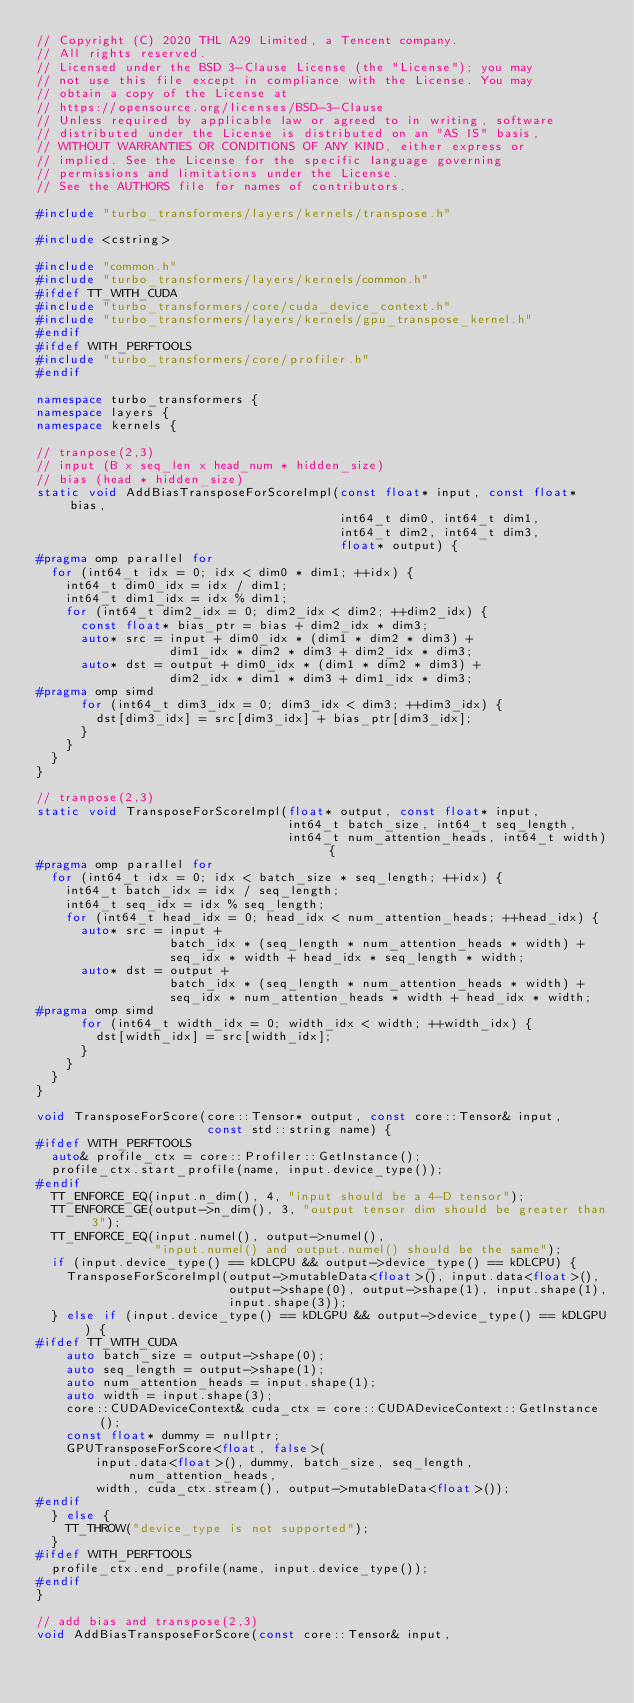Convert code to text. <code><loc_0><loc_0><loc_500><loc_500><_C++_>// Copyright (C) 2020 THL A29 Limited, a Tencent company.
// All rights reserved.
// Licensed under the BSD 3-Clause License (the "License"); you may
// not use this file except in compliance with the License. You may
// obtain a copy of the License at
// https://opensource.org/licenses/BSD-3-Clause
// Unless required by applicable law or agreed to in writing, software
// distributed under the License is distributed on an "AS IS" basis,
// WITHOUT WARRANTIES OR CONDITIONS OF ANY KIND, either express or
// implied. See the License for the specific language governing
// permissions and limitations under the License.
// See the AUTHORS file for names of contributors.

#include "turbo_transformers/layers/kernels/transpose.h"

#include <cstring>

#include "common.h"
#include "turbo_transformers/layers/kernels/common.h"
#ifdef TT_WITH_CUDA
#include "turbo_transformers/core/cuda_device_context.h"
#include "turbo_transformers/layers/kernels/gpu_transpose_kernel.h"
#endif
#ifdef WITH_PERFTOOLS
#include "turbo_transformers/core/profiler.h"
#endif

namespace turbo_transformers {
namespace layers {
namespace kernels {

// tranpose(2,3)
// input (B x seq_len x head_num * hidden_size)
// bias (head * hidden_size)
static void AddBiasTransposeForScoreImpl(const float* input, const float* bias,
                                         int64_t dim0, int64_t dim1,
                                         int64_t dim2, int64_t dim3,
                                         float* output) {
#pragma omp parallel for
  for (int64_t idx = 0; idx < dim0 * dim1; ++idx) {
    int64_t dim0_idx = idx / dim1;
    int64_t dim1_idx = idx % dim1;
    for (int64_t dim2_idx = 0; dim2_idx < dim2; ++dim2_idx) {
      const float* bias_ptr = bias + dim2_idx * dim3;
      auto* src = input + dim0_idx * (dim1 * dim2 * dim3) +
                  dim1_idx * dim2 * dim3 + dim2_idx * dim3;
      auto* dst = output + dim0_idx * (dim1 * dim2 * dim3) +
                  dim2_idx * dim1 * dim3 + dim1_idx * dim3;
#pragma omp simd
      for (int64_t dim3_idx = 0; dim3_idx < dim3; ++dim3_idx) {
        dst[dim3_idx] = src[dim3_idx] + bias_ptr[dim3_idx];
      }
    }
  }
}

// tranpose(2,3)
static void TransposeForScoreImpl(float* output, const float* input,
                                  int64_t batch_size, int64_t seq_length,
                                  int64_t num_attention_heads, int64_t width) {
#pragma omp parallel for
  for (int64_t idx = 0; idx < batch_size * seq_length; ++idx) {
    int64_t batch_idx = idx / seq_length;
    int64_t seq_idx = idx % seq_length;
    for (int64_t head_idx = 0; head_idx < num_attention_heads; ++head_idx) {
      auto* src = input +
                  batch_idx * (seq_length * num_attention_heads * width) +
                  seq_idx * width + head_idx * seq_length * width;
      auto* dst = output +
                  batch_idx * (seq_length * num_attention_heads * width) +
                  seq_idx * num_attention_heads * width + head_idx * width;
#pragma omp simd
      for (int64_t width_idx = 0; width_idx < width; ++width_idx) {
        dst[width_idx] = src[width_idx];
      }
    }
  }
}

void TransposeForScore(core::Tensor* output, const core::Tensor& input,
                       const std::string name) {
#ifdef WITH_PERFTOOLS
  auto& profile_ctx = core::Profiler::GetInstance();
  profile_ctx.start_profile(name, input.device_type());
#endif
  TT_ENFORCE_EQ(input.n_dim(), 4, "input should be a 4-D tensor");
  TT_ENFORCE_GE(output->n_dim(), 3, "output tensor dim should be greater than 3");
  TT_ENFORCE_EQ(input.numel(), output->numel(),
                "input.numel() and output.numel() should be the same");
  if (input.device_type() == kDLCPU && output->device_type() == kDLCPU) {
    TransposeForScoreImpl(output->mutableData<float>(), input.data<float>(),
                          output->shape(0), output->shape(1), input.shape(1),
                          input.shape(3));
  } else if (input.device_type() == kDLGPU && output->device_type() == kDLGPU) {
#ifdef TT_WITH_CUDA
    auto batch_size = output->shape(0);
    auto seq_length = output->shape(1);
    auto num_attention_heads = input.shape(1);
    auto width = input.shape(3);
    core::CUDADeviceContext& cuda_ctx = core::CUDADeviceContext::GetInstance();
    const float* dummy = nullptr;
    GPUTransposeForScore<float, false>(
        input.data<float>(), dummy, batch_size, seq_length, num_attention_heads,
        width, cuda_ctx.stream(), output->mutableData<float>());
#endif
  } else {
    TT_THROW("device_type is not supported");
  }
#ifdef WITH_PERFTOOLS
  profile_ctx.end_profile(name, input.device_type());
#endif
}

// add bias and transpose(2,3)
void AddBiasTransposeForScore(const core::Tensor& input,</code> 